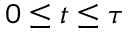<formula> <loc_0><loc_0><loc_500><loc_500>0 \leq t \leq \tau</formula> 